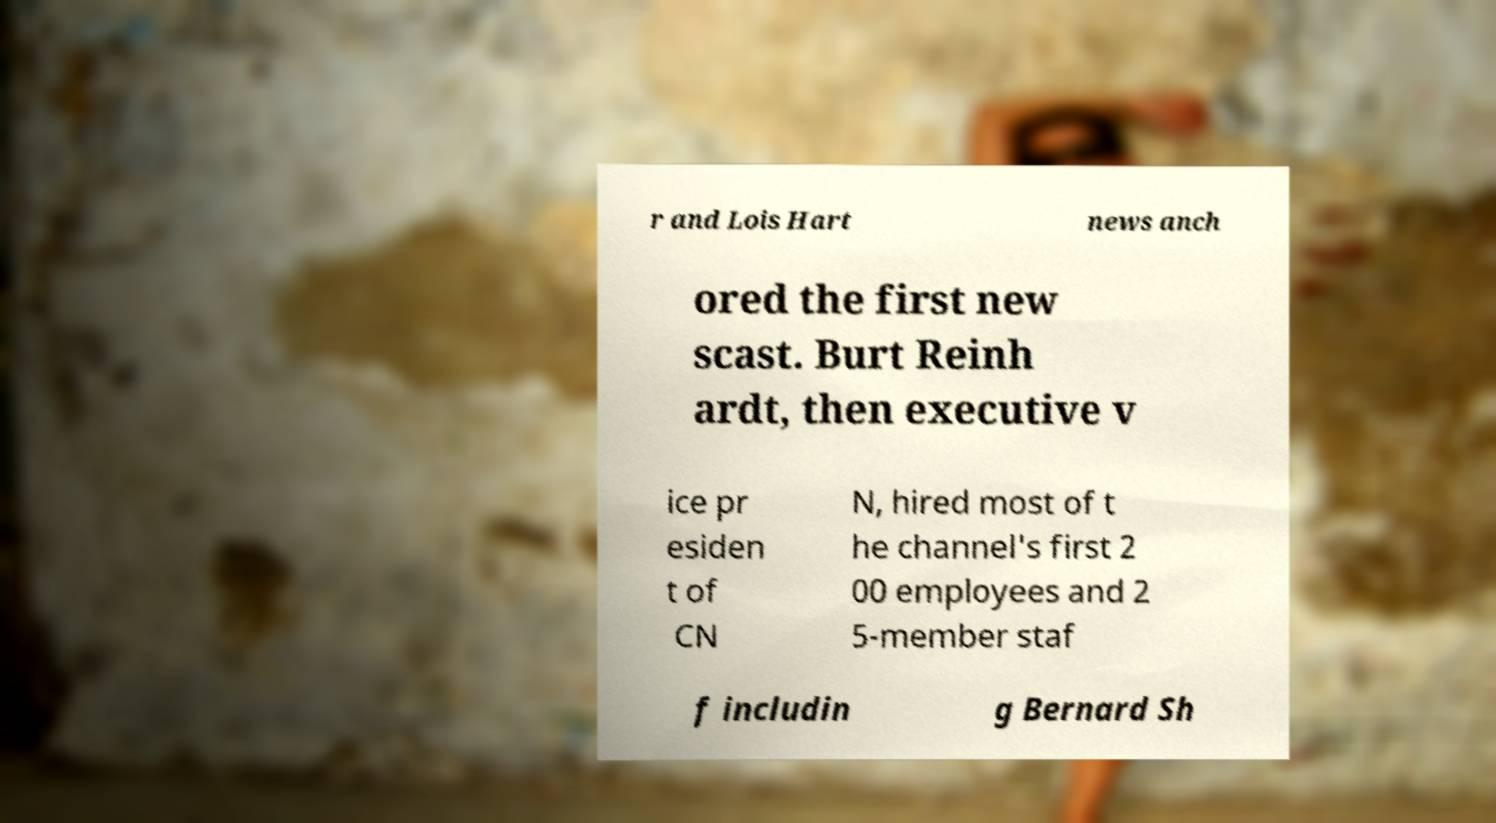What messages or text are displayed in this image? I need them in a readable, typed format. r and Lois Hart news anch ored the first new scast. Burt Reinh ardt, then executive v ice pr esiden t of CN N, hired most of t he channel's first 2 00 employees and 2 5-member staf f includin g Bernard Sh 